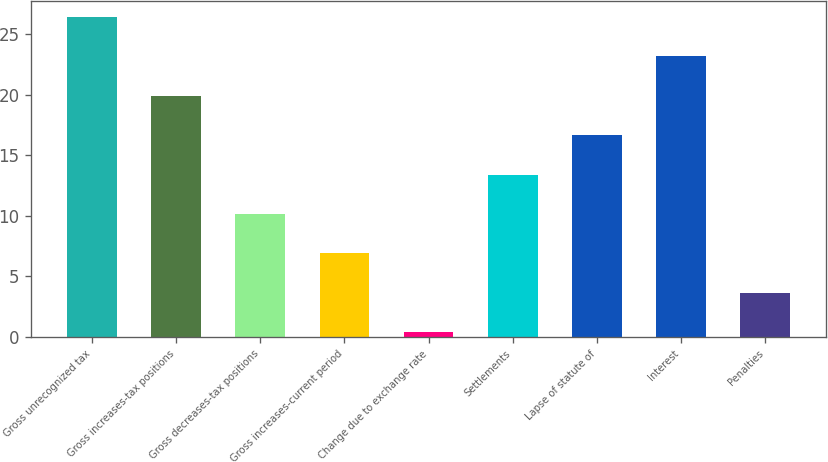Convert chart. <chart><loc_0><loc_0><loc_500><loc_500><bar_chart><fcel>Gross unrecognized tax<fcel>Gross increases-tax positions<fcel>Gross decreases-tax positions<fcel>Gross increases-current period<fcel>Change due to exchange rate<fcel>Settlements<fcel>Lapse of statute of<fcel>Interest<fcel>Penalties<nl><fcel>26.4<fcel>19.9<fcel>10.15<fcel>6.9<fcel>0.4<fcel>13.4<fcel>16.65<fcel>23.15<fcel>3.65<nl></chart> 